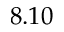<formula> <loc_0><loc_0><loc_500><loc_500>8 . 1 0</formula> 